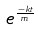<formula> <loc_0><loc_0><loc_500><loc_500>e ^ { \frac { - k t } { m } }</formula> 